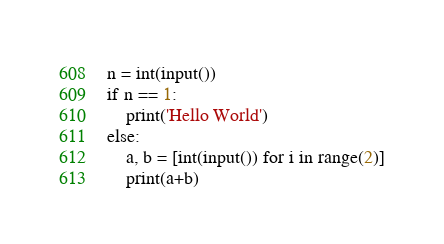Convert code to text. <code><loc_0><loc_0><loc_500><loc_500><_Python_>n = int(input())
if n == 1:
    print('Hello World')
else:
    a, b = [int(input()) for i in range(2)]
    print(a+b)
</code> 